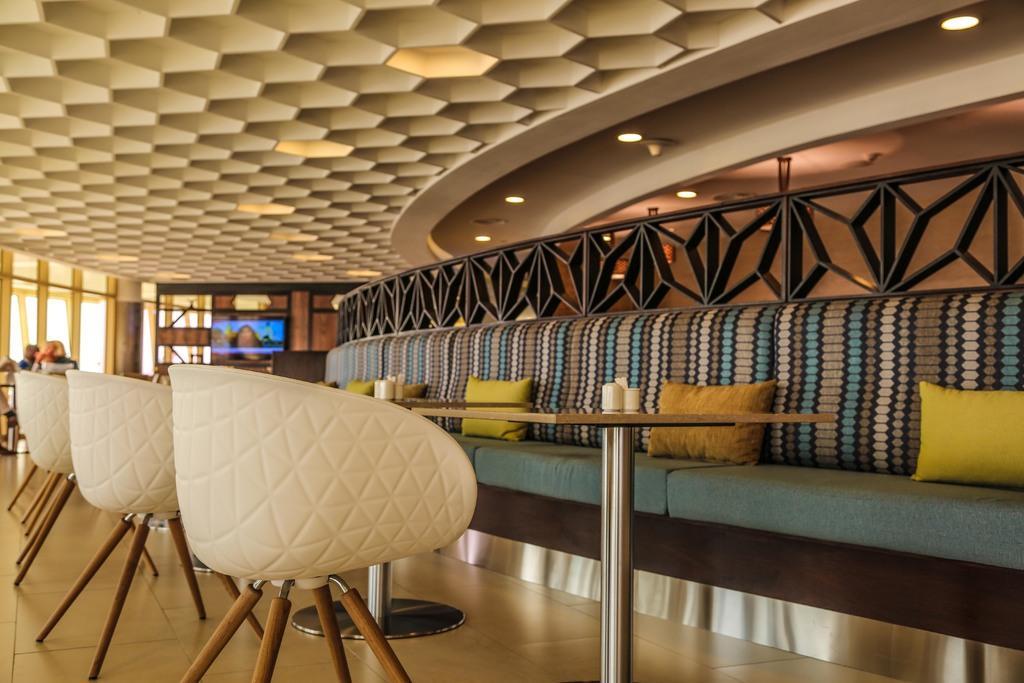Describe this image in one or two sentences. These are the chairs and tables. This looks like a couch with cushions on it. I can see the ceiling lights, which are attached to the roof. This looks like a ceiling. I can see few people sitting. This is the television. 